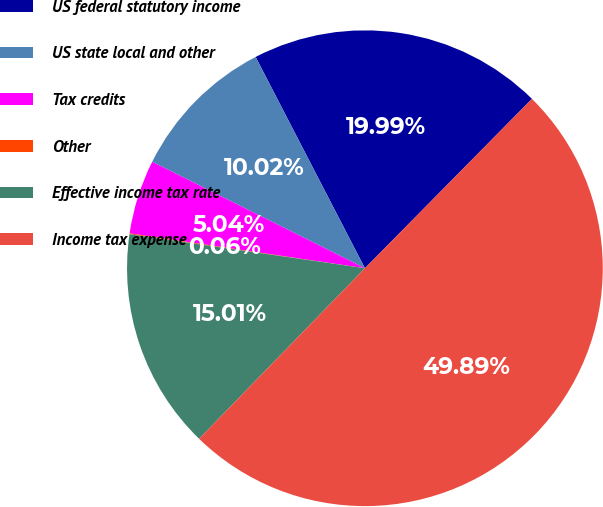Convert chart. <chart><loc_0><loc_0><loc_500><loc_500><pie_chart><fcel>US federal statutory income<fcel>US state local and other<fcel>Tax credits<fcel>Other<fcel>Effective income tax rate<fcel>Income tax expense<nl><fcel>19.99%<fcel>10.02%<fcel>5.04%<fcel>0.06%<fcel>15.01%<fcel>49.89%<nl></chart> 